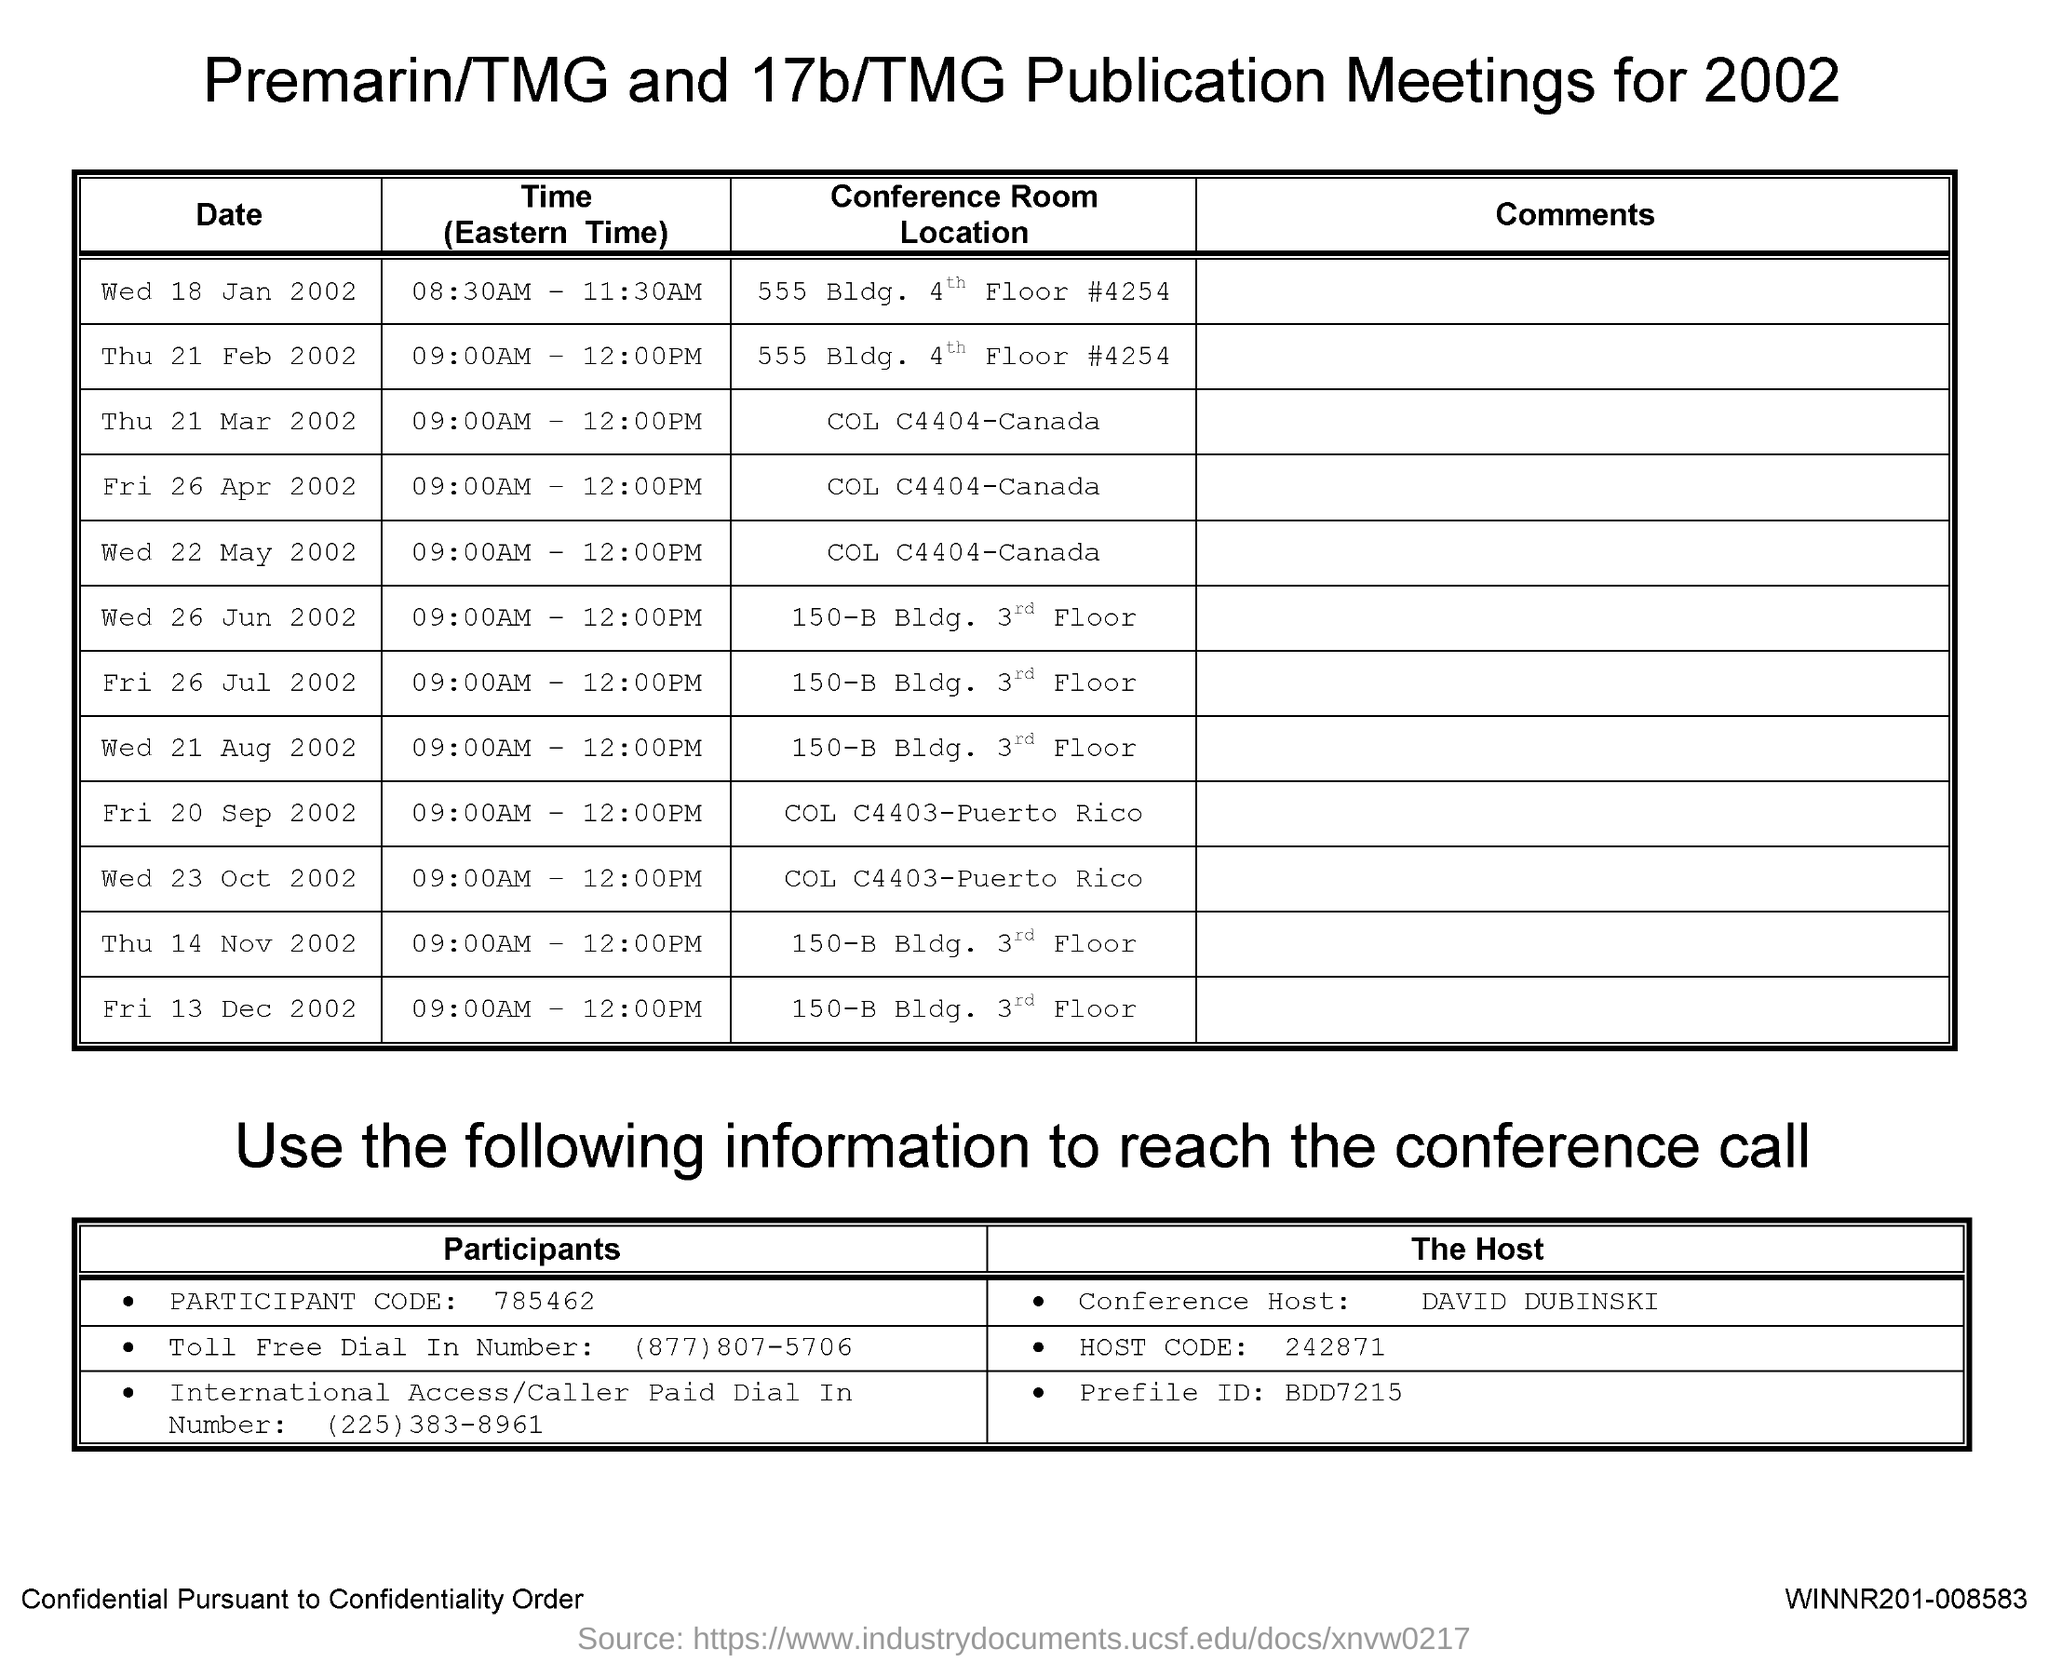Highlight a few significant elements in this photo. The participant code mentioned in this document is 785462. The Host Code referenced in this document is 242871... The Premarin/TMG and 17b/TMG Publication Meeting will take place on Wednesday, January 18, 2002, from 8:30AM to 11:30AM. The conference host is David Dubinski. 